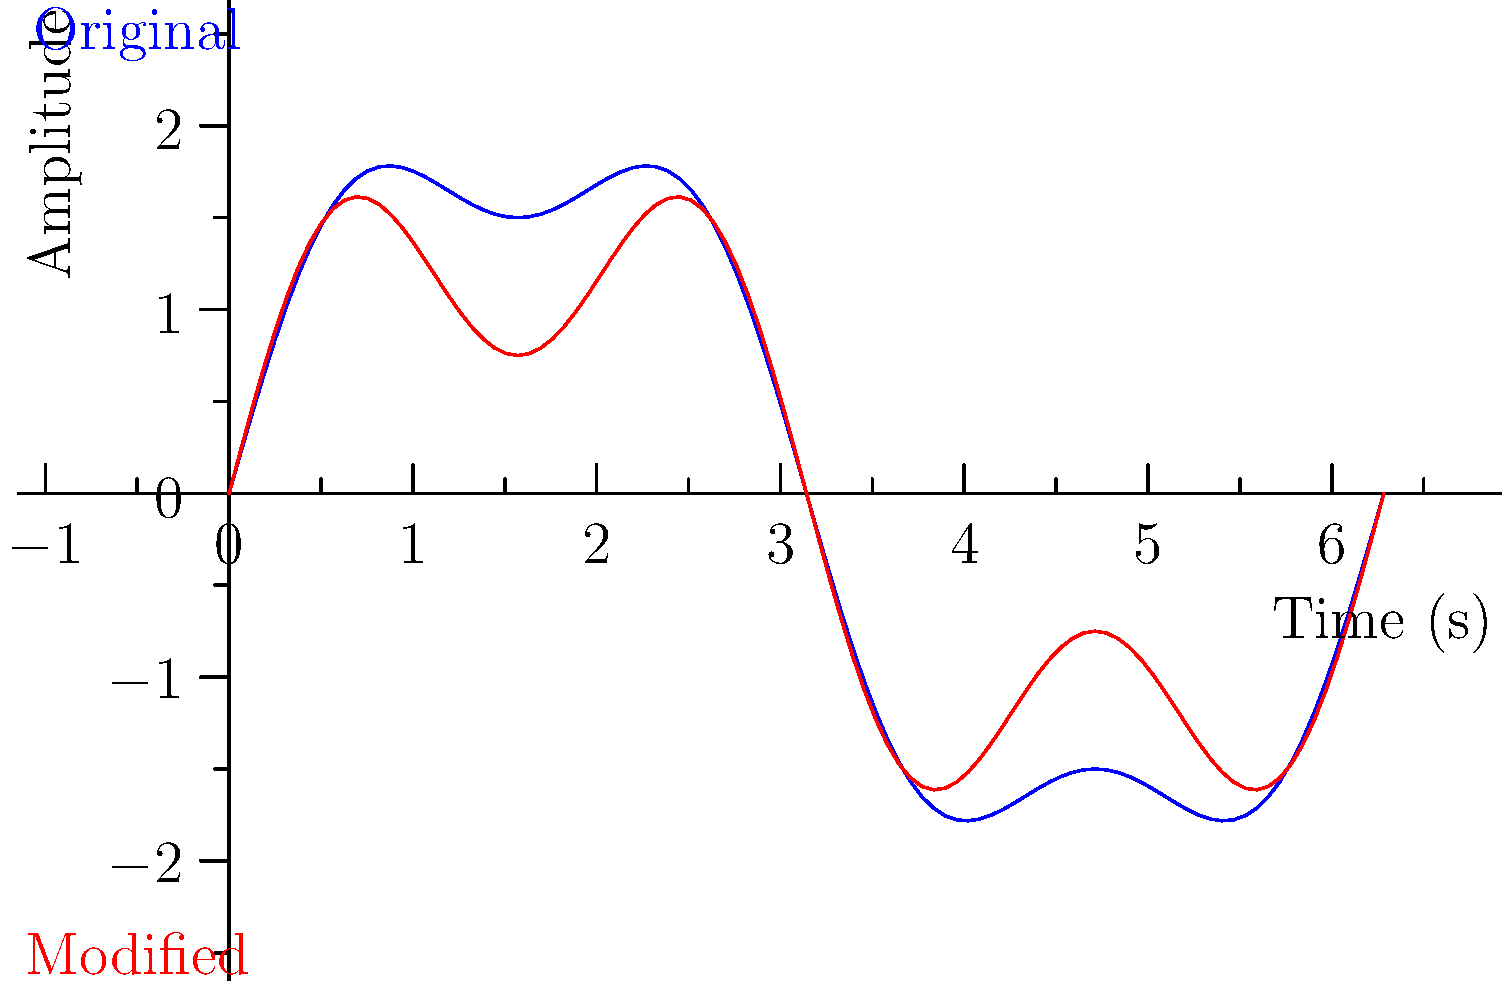In a court recording authentication case, you're presented with two audio waveforms: the original (blue) and a potentially modified version (red). The waveforms can be described by the functions:

Original: $f(t) = 2\sin(t) + 0.5\sin(3t)$
Modified: $g(t) = 1.5\sin(t) + 0.75\sin(3t)$

Where $t$ represents time in seconds. Calculate the percentage change in the amplitude of the fundamental frequency (represented by the $\sin(t)$ term) between the original and modified waveforms. To solve this problem, we'll follow these steps:

1) Identify the amplitudes of the fundamental frequency in both waveforms:
   - Original: The coefficient of $\sin(t)$ in $f(t)$ is 2
   - Modified: The coefficient of $\sin(t)$ in $g(t)$ is 1.5

2) Calculate the difference in amplitude:
   $2 - 1.5 = 0.5$

3) Calculate the percentage change:
   Percentage change = $\frac{\text{Change in value}}{\text{Original value}} \times 100\%$
   
   $= \frac{0.5}{2} \times 100\%$
   
   $= 0.25 \times 100\%$
   
   $= 25\%$

4) Since the amplitude decreased, we express this as a 25% decrease.

Therefore, the amplitude of the fundamental frequency decreased by 25% in the modified waveform compared to the original.
Answer: 25% decrease 